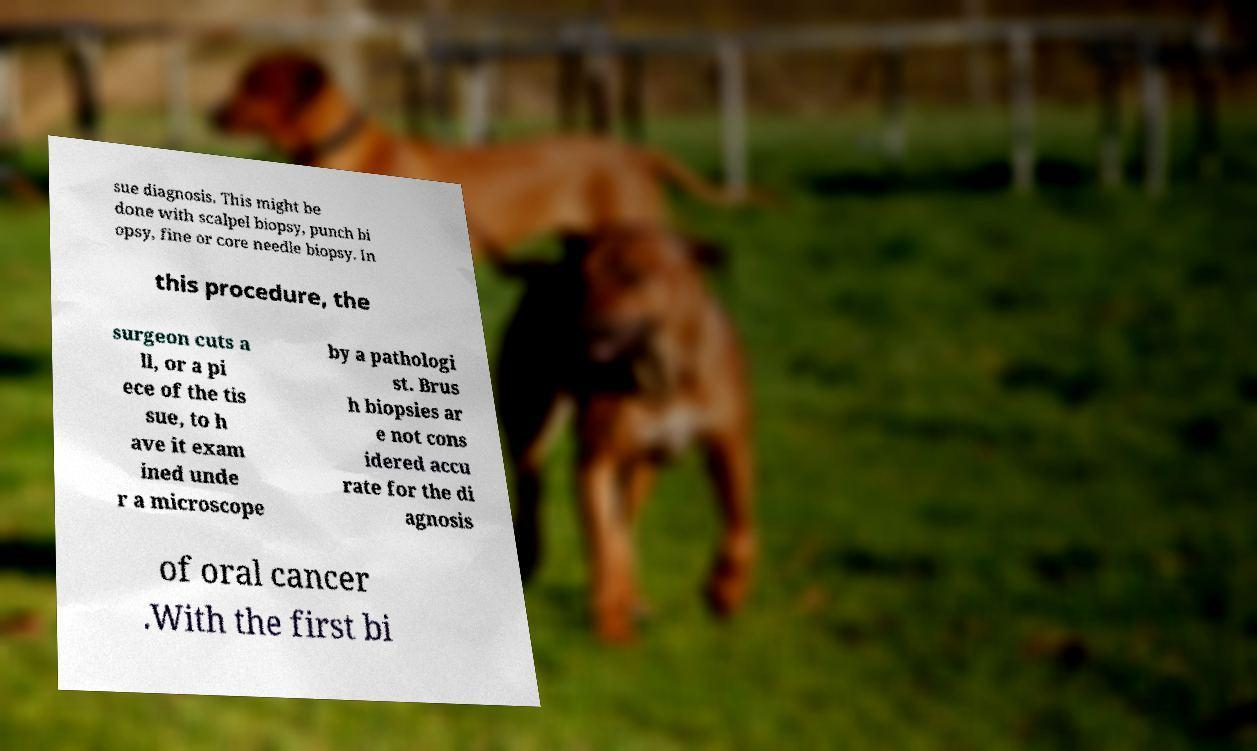Can you read and provide the text displayed in the image?This photo seems to have some interesting text. Can you extract and type it out for me? sue diagnosis. This might be done with scalpel biopsy, punch bi opsy, fine or core needle biopsy. In this procedure, the surgeon cuts a ll, or a pi ece of the tis sue, to h ave it exam ined unde r a microscope by a pathologi st. Brus h biopsies ar e not cons idered accu rate for the di agnosis of oral cancer .With the first bi 